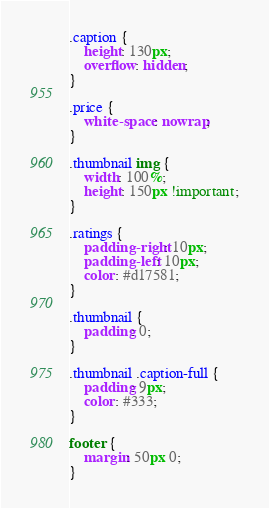Convert code to text. <code><loc_0><loc_0><loc_500><loc_500><_CSS_>
.caption {
    height: 130px;
    overflow: hidden;
}

.price {
    white-space: nowrap;
}

.thumbnail img {
    width: 100%;
    height: 150px !important;
}

.ratings {
    padding-right: 10px;
    padding-left: 10px;
    color: #d17581;
}

.thumbnail {
    padding: 0;
}

.thumbnail .caption-full {
    padding: 9px;
    color: #333;
}

footer {
    margin: 50px 0;
}
</code> 